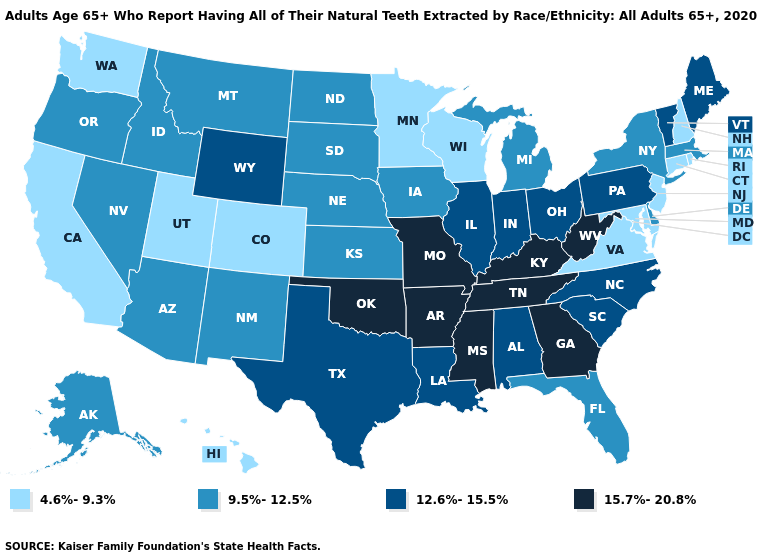Does Wyoming have the highest value in the West?
Short answer required. Yes. Which states have the lowest value in the USA?
Give a very brief answer. California, Colorado, Connecticut, Hawaii, Maryland, Minnesota, New Hampshire, New Jersey, Rhode Island, Utah, Virginia, Washington, Wisconsin. Does Arkansas have the highest value in the USA?
Be succinct. Yes. Is the legend a continuous bar?
Keep it brief. No. Does the map have missing data?
Give a very brief answer. No. Name the states that have a value in the range 4.6%-9.3%?
Give a very brief answer. California, Colorado, Connecticut, Hawaii, Maryland, Minnesota, New Hampshire, New Jersey, Rhode Island, Utah, Virginia, Washington, Wisconsin. What is the value of Minnesota?
Quick response, please. 4.6%-9.3%. Does Wisconsin have the lowest value in the MidWest?
Concise answer only. Yes. Which states have the lowest value in the West?
Answer briefly. California, Colorado, Hawaii, Utah, Washington. Does Wisconsin have the highest value in the USA?
Short answer required. No. Name the states that have a value in the range 4.6%-9.3%?
Answer briefly. California, Colorado, Connecticut, Hawaii, Maryland, Minnesota, New Hampshire, New Jersey, Rhode Island, Utah, Virginia, Washington, Wisconsin. What is the value of Hawaii?
Write a very short answer. 4.6%-9.3%. Does the first symbol in the legend represent the smallest category?
Quick response, please. Yes. What is the lowest value in states that border Massachusetts?
Short answer required. 4.6%-9.3%. Name the states that have a value in the range 15.7%-20.8%?
Be succinct. Arkansas, Georgia, Kentucky, Mississippi, Missouri, Oklahoma, Tennessee, West Virginia. 